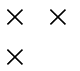<formula> <loc_0><loc_0><loc_500><loc_500>\begin{matrix} \times & \times \\ \times & \end{matrix}</formula> 